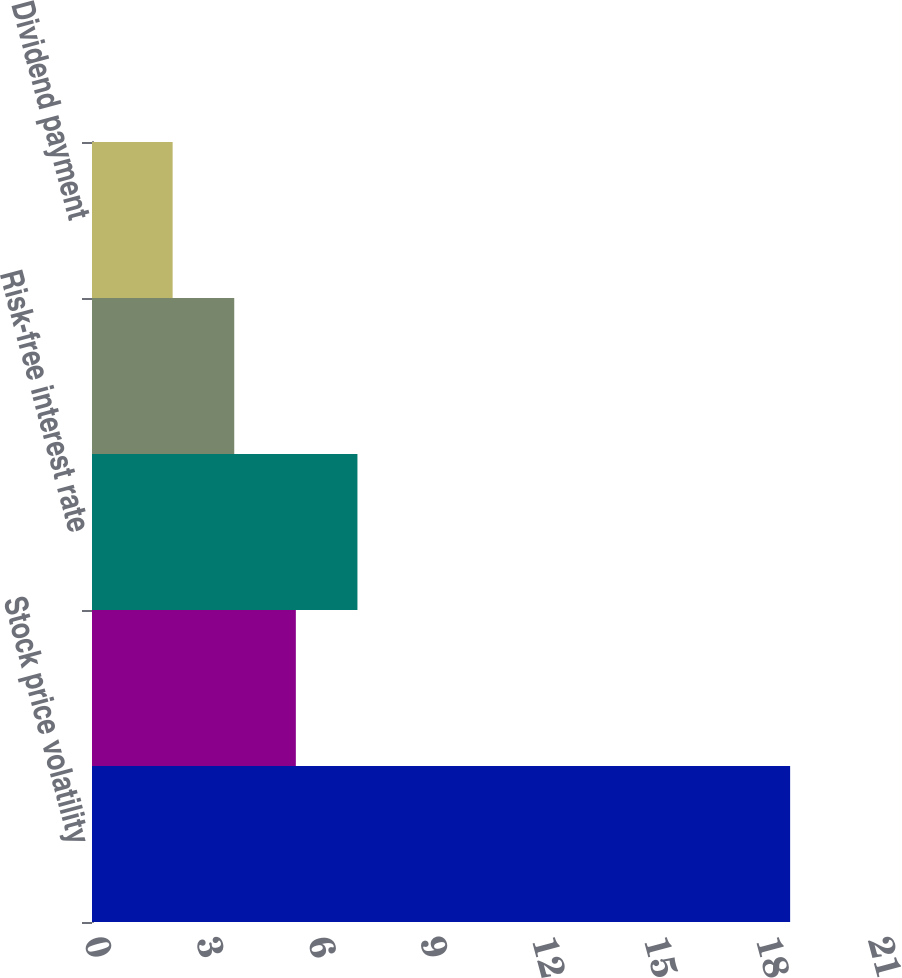Convert chart. <chart><loc_0><loc_0><loc_500><loc_500><bar_chart><fcel>Stock price volatility<fcel>Expected term in years<fcel>Risk-free interest rate<fcel>Dividend yield<fcel>Dividend payment<nl><fcel>18.7<fcel>5.46<fcel>7.11<fcel>3.81<fcel>2.16<nl></chart> 